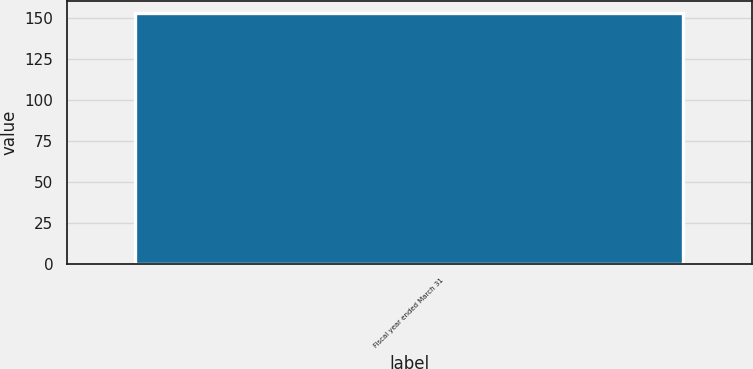<chart> <loc_0><loc_0><loc_500><loc_500><bar_chart><fcel>Fiscal year ended March 31<nl><fcel>153<nl></chart> 